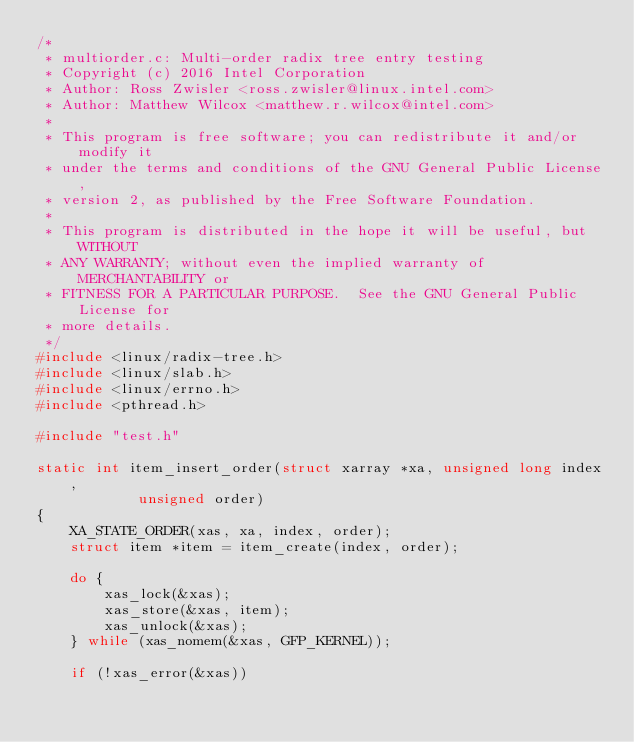<code> <loc_0><loc_0><loc_500><loc_500><_C_>/*
 * multiorder.c: Multi-order radix tree entry testing
 * Copyright (c) 2016 Intel Corporation
 * Author: Ross Zwisler <ross.zwisler@linux.intel.com>
 * Author: Matthew Wilcox <matthew.r.wilcox@intel.com>
 *
 * This program is free software; you can redistribute it and/or modify it
 * under the terms and conditions of the GNU General Public License,
 * version 2, as published by the Free Software Foundation.
 *
 * This program is distributed in the hope it will be useful, but WITHOUT
 * ANY WARRANTY; without even the implied warranty of MERCHANTABILITY or
 * FITNESS FOR A PARTICULAR PURPOSE.  See the GNU General Public License for
 * more details.
 */
#include <linux/radix-tree.h>
#include <linux/slab.h>
#include <linux/errno.h>
#include <pthread.h>

#include "test.h"

static int item_insert_order(struct xarray *xa, unsigned long index,
			unsigned order)
{
	XA_STATE_ORDER(xas, xa, index, order);
	struct item *item = item_create(index, order);

	do {
		xas_lock(&xas);
		xas_store(&xas, item);
		xas_unlock(&xas);
	} while (xas_nomem(&xas, GFP_KERNEL));

	if (!xas_error(&xas))</code> 